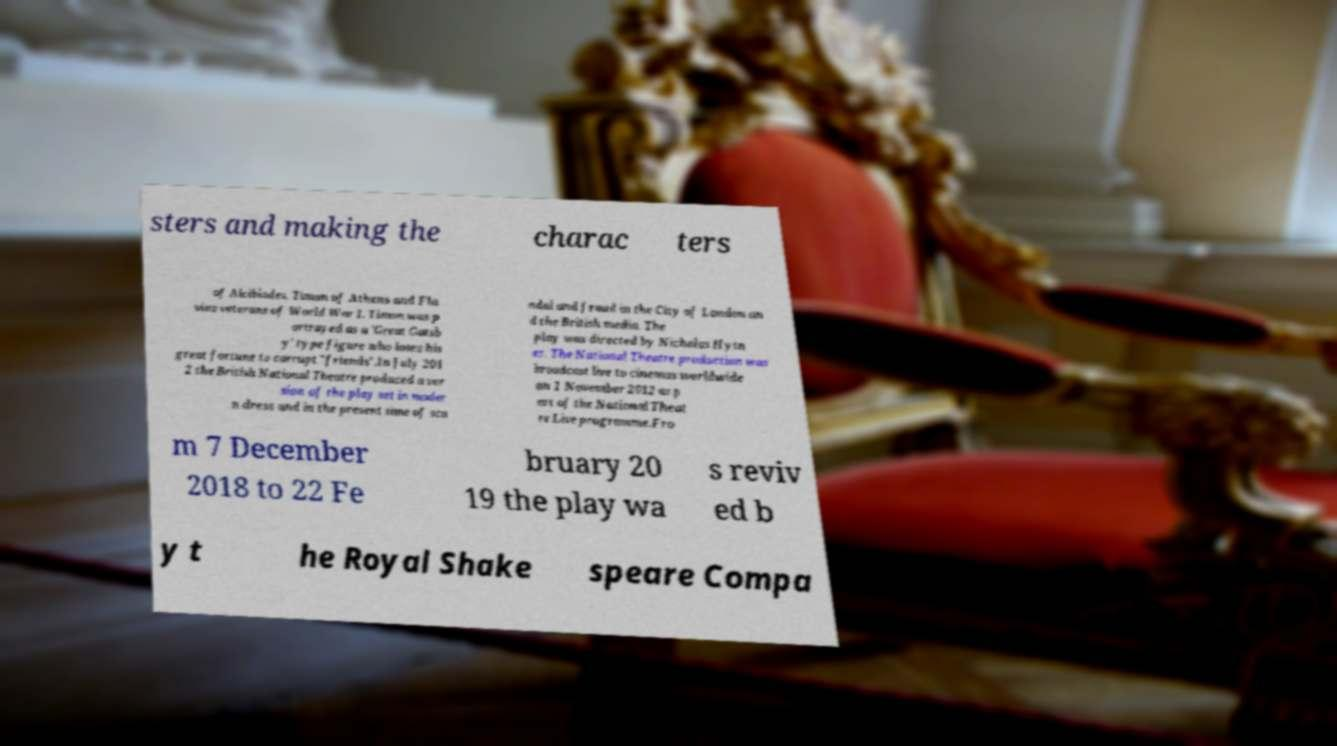Could you extract and type out the text from this image? sters and making the charac ters of Alcibiades, Timon of Athens and Fla vius veterans of World War I. Timon was p ortrayed as a 'Great Gatsb y' type figure who loses his great fortune to corrupt "friends".In July 201 2 the British National Theatre produced a ver sion of the play set in moder n dress and in the present time of sca ndal and fraud in the City of London an d the British media. The play was directed by Nicholas Hytn er. The National Theatre production was broadcast live to cinemas worldwide on 1 November 2012 as p art of the National Theat re Live programme.Fro m 7 December 2018 to 22 Fe bruary 20 19 the play wa s reviv ed b y t he Royal Shake speare Compa 